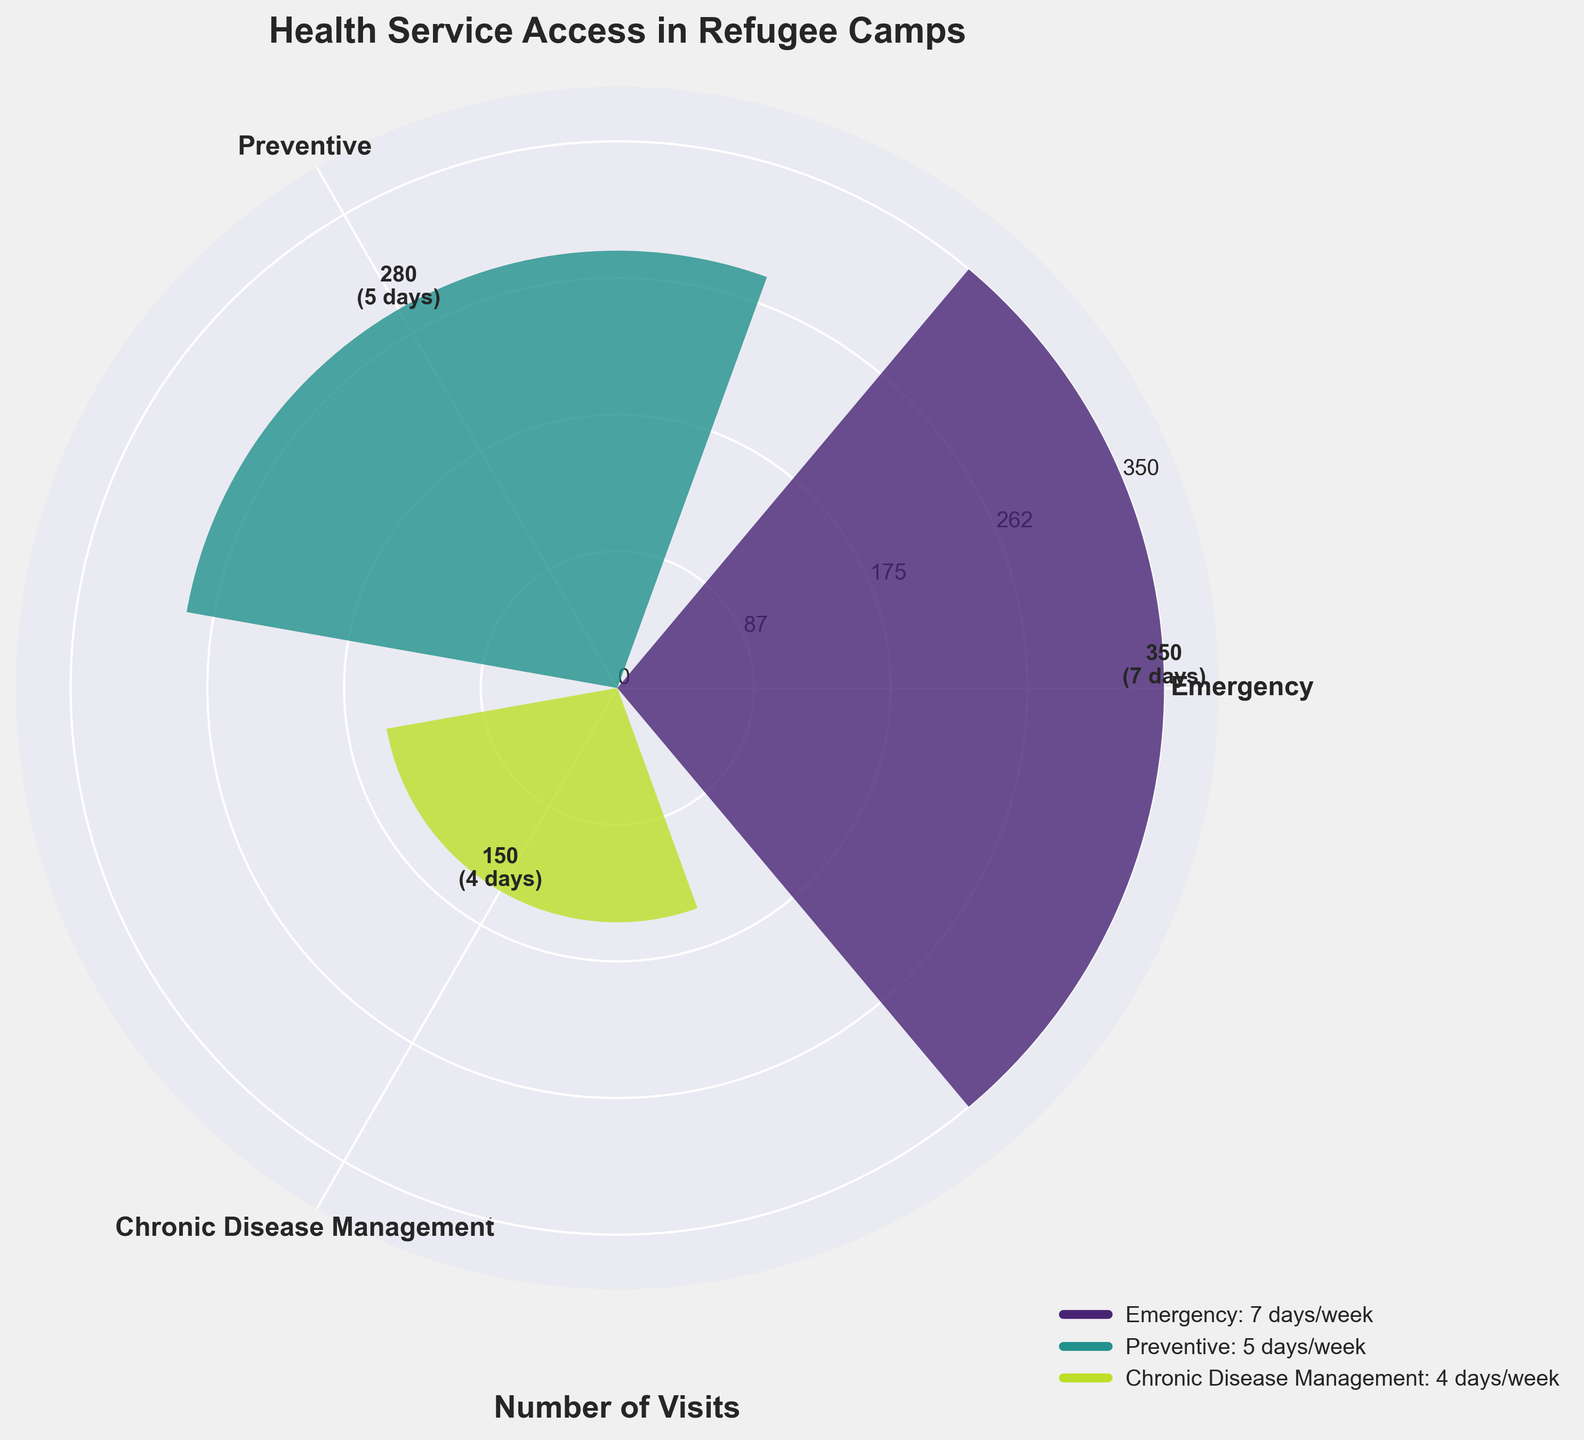How many types of services are shown in the figure? The figure displays bars with labels indicating the type of services. By counting these labels, we identify that there are three types of services.
Answer: 3 types What is the number of visits for the preventive services? Look for the bar labeled "Preventive" and read the value on top of the bar. The number of visits displayed is 280.
Answer: 280 Which service has the highest number of visits? Identify the bar with the maximum height. The "Emergency" service has the highest number with 350 visits.
Answer: Emergency How many days per week is the chronic disease management service available? Refer to the label on the bar for "Chronic Disease Management" which shows the service availability in days/week. It is available for 4 days/week.
Answer: 4 days/week What is the average number of visits across all services? Sum the number of visits for all services and divide by the count of services: (350 + 280 + 150) / 3 = 780 / 3 = 260.
Answer: 260 Which service has the least number of visits? Look for the bar with the least height. The "Chronic Disease Management" service has the fewest visits with 150.
Answer: Chronic Disease Management How many more visits do emergency services have compared to preventive services? Subtract the number of visits for preventive services from the number for emergency services: 350 - 280 = 70.
Answer: 70 Which service is offered the most frequently in terms of days per week? Check the labels for service availability (days/week) and identify the highest. The "Emergency" service is available 7 days/week, which is the most frequent.
Answer: Emergency If the number of visits for chronic disease management doubled, what would be the new total number of visits across all services? Calculate the number of visits if it doubled (150 * 2 = 300), then sum with the other services: 350 + 280 + 300 = 930.
Answer: 930 How does the number of days per week for preventive services compare to emergency services? Compare the days mentioned for both services: Preventive (5 days/week) and Emergency (7 days/week). Preventive services are available 2 days fewer.
Answer: 2 days fewer 